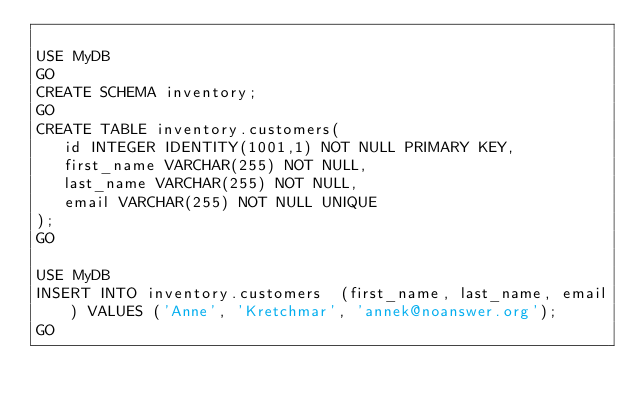Convert code to text. <code><loc_0><loc_0><loc_500><loc_500><_SQL_>
USE MyDB
GO
CREATE SCHEMA inventory;
GO
CREATE TABLE inventory.customers(
   id INTEGER IDENTITY(1001,1) NOT NULL PRIMARY KEY,
   first_name VARCHAR(255) NOT NULL,
   last_name VARCHAR(255) NOT NULL,
   email VARCHAR(255) NOT NULL UNIQUE
);
GO

USE MyDB
INSERT INTO inventory.customers  (first_name, last_name, email) VALUES ('Anne', 'Kretchmar', 'annek@noanswer.org');
GO


</code> 